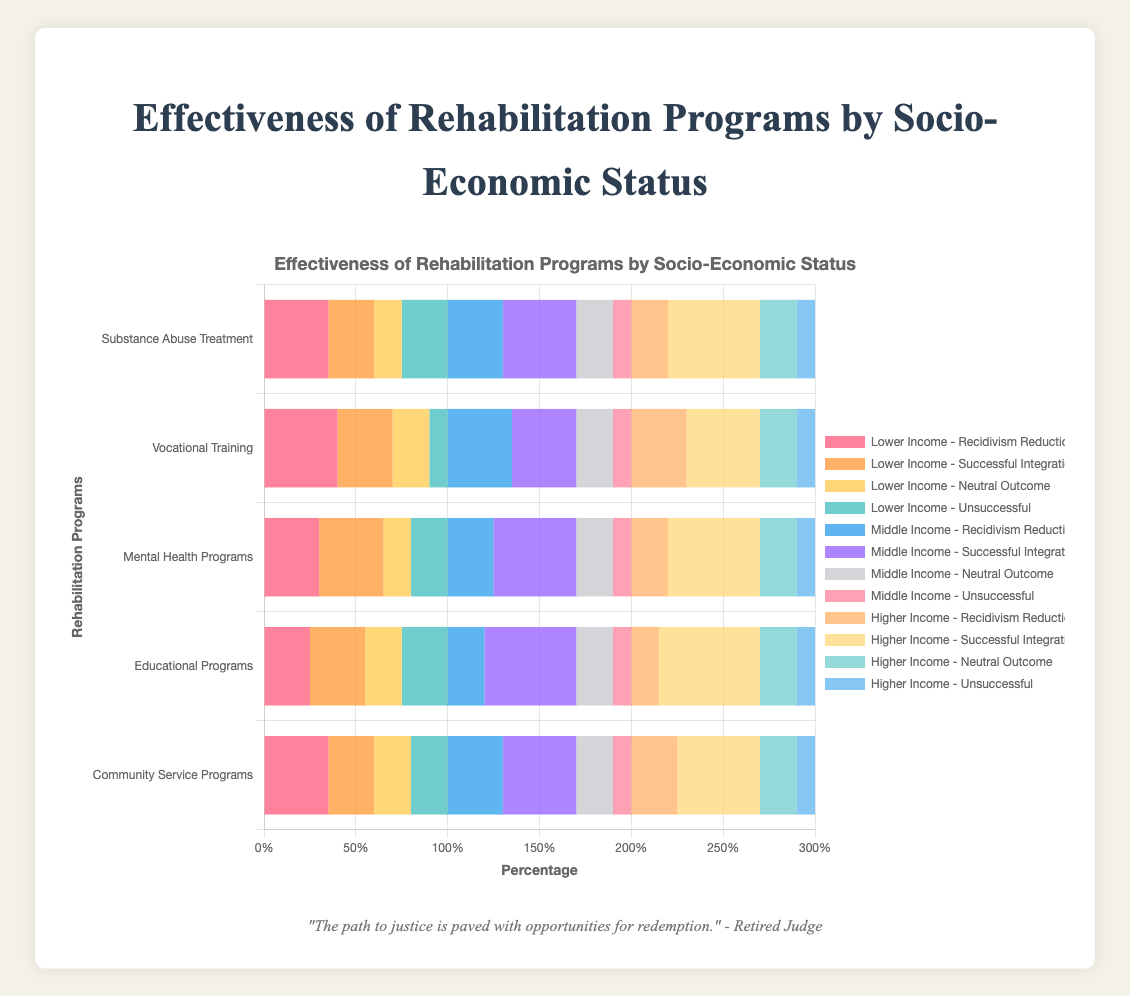What is the total percentage of "Recidivism Reduction" across all socio-economic statuses for the "Substance Abuse Treatment" program? To find the total percentage, sum the "Recidivism Reduction" values for Lower Income (35%), Middle Income (30%), and Higher Income (20%). 35 + 30 + 20 = 85.
Answer: 85 Which socio-economic status has the highest percentage of "Successful Integration" in the "Educational Programs"? Compare the "Successful Integration" values for Lower Income (30%), Middle Income (50%), and Higher Income (55%). The Higher Income group has the highest percentage at 55%.
Answer: Higher Income For the "Vocational Training" program, is the percentage of "Unsuccessful" cases the same across all socio-economic statuses? Compare the "Unsuccessful" percentages for Lower Income (10%), Middle Income (10%), and Higher Income (10%). All values are 10%, so they are the same.
Answer: Yes Which program shows the lowest percentage of "Recidivism Reduction" for Higher Income individuals? Check the "Recidivism Reduction" values for Higher Income in each program: Substance Abuse Treatment (20%), Vocational Training (30%), Mental Health Programs (20%), Educational Programs (15%), Community Service Programs (25%). The lowest percentage is in the Educational Programs at 15%.
Answer: Educational Programs What is the difference in "Successful Integration" percentages between Lower Income and Higher Income groups for "Mental Health Programs"? Subtract the "Successful Integration" percentage of Lower Income (35%) from Higher Income (50%). 50 - 35 = 15.
Answer: 15 Which socio-economic status has the highest combined percentage of "Recidivism Reduction" and "Successful Integration" for "Community Service Programs"? Calculate the sum for each status: Lower Income (35% + 25% = 60%), Middle Income (30% + 40% = 70%), Higher Income (25% + 45% = 70%). Both Middle and Higher Income groups have the highest combined percentage of 70%.
Answer: Middle and Higher Income For the "Substance Abuse Treatment" program, what is the sum of "Neutral Outcome" percentages for all socio-economic statuses? Add the "Neutral Outcome" values for Lower Income (15%), Middle Income (20%), and Higher Income (20%). 15 + 20 + 20 = 55.
Answer: 55 Look at the Lower Income "Vocational Training" bars. Which proportion is smaller: "Neutral Outcome" or "Successful Integration"? The "Neutral Outcome" bar is 20% and the "Successful Integration" bar is 30%. Therefore, "Neutral Outcome" is smaller.
Answer: Neutral Outcome What is the difference in the "Unsuccessful" percentage between Middle Income and Lower Income groups for "Educational Programs"? Subtract the "Unsuccessful" percentage for Middle Income (10%) from Lower Income (25%). 25 - 10 = 15.
Answer: 15 